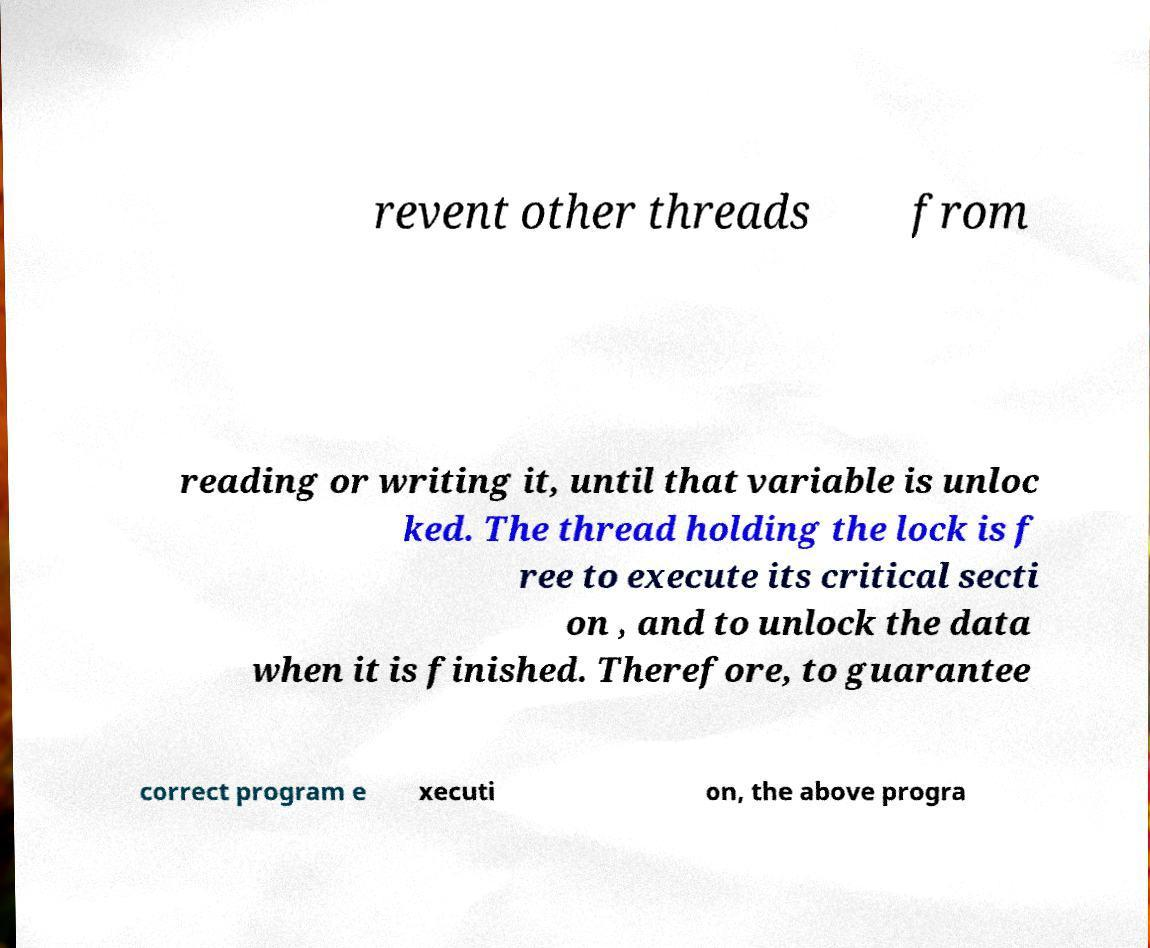Can you read and provide the text displayed in the image?This photo seems to have some interesting text. Can you extract and type it out for me? revent other threads from reading or writing it, until that variable is unloc ked. The thread holding the lock is f ree to execute its critical secti on , and to unlock the data when it is finished. Therefore, to guarantee correct program e xecuti on, the above progra 